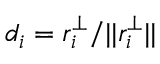<formula> <loc_0><loc_0><loc_500><loc_500>d _ { i } = r _ { i } ^ { \perp } / | | r _ { i } ^ { \perp } | |</formula> 